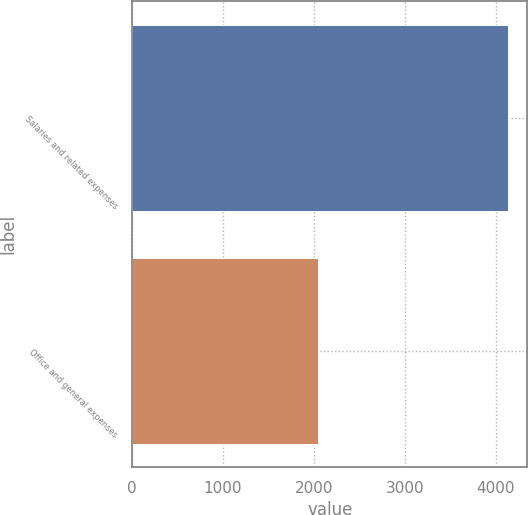<chart> <loc_0><loc_0><loc_500><loc_500><bar_chart><fcel>Salaries and related expenses<fcel>Office and general expenses<nl><fcel>4139.2<fcel>2044.8<nl></chart> 